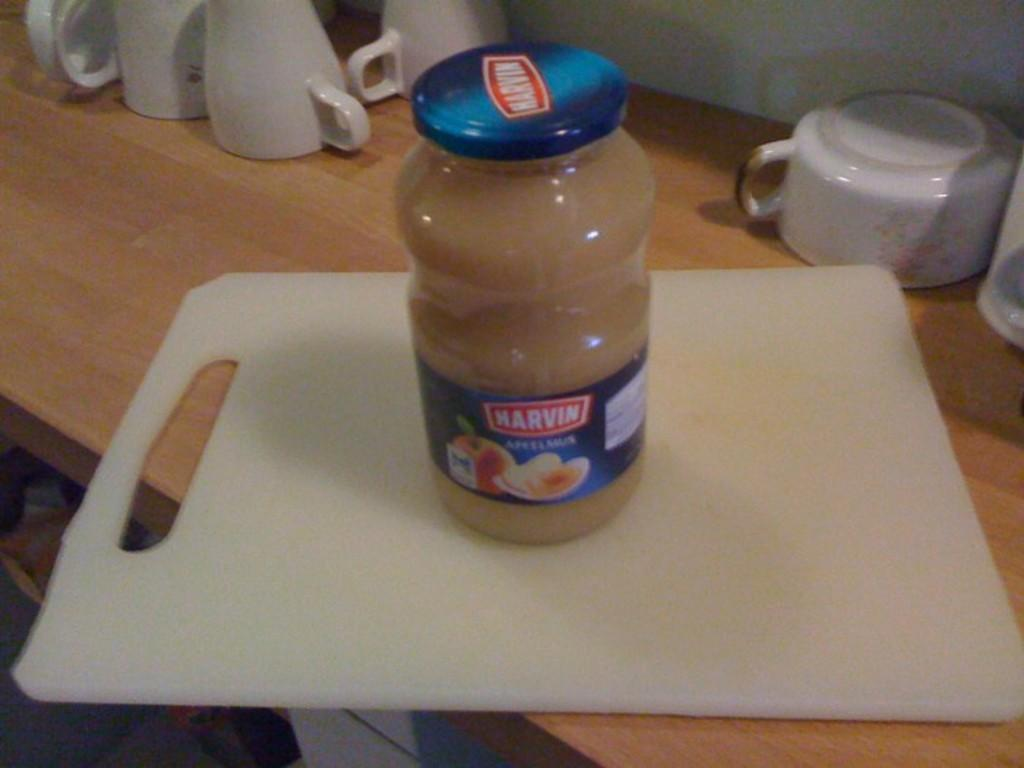Provide a one-sentence caption for the provided image. A jar of MArvin applesauce sitting on a white cutting board. 